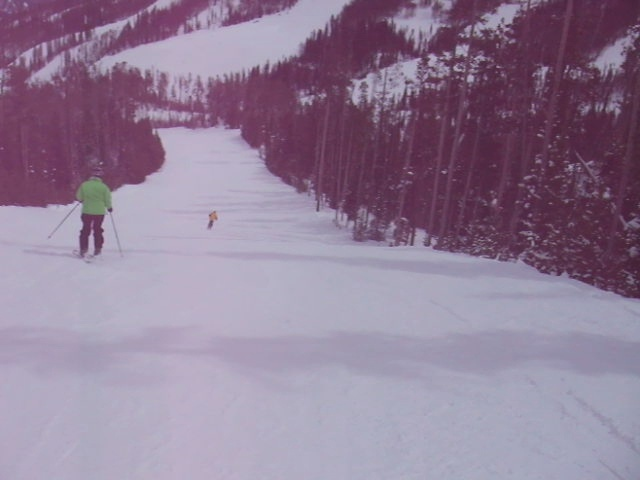Describe the objects in this image and their specific colors. I can see people in purple, gray, and darkgray tones, skis in purple, darkgray, and gray tones, and people in purple, darkgray, and gray tones in this image. 